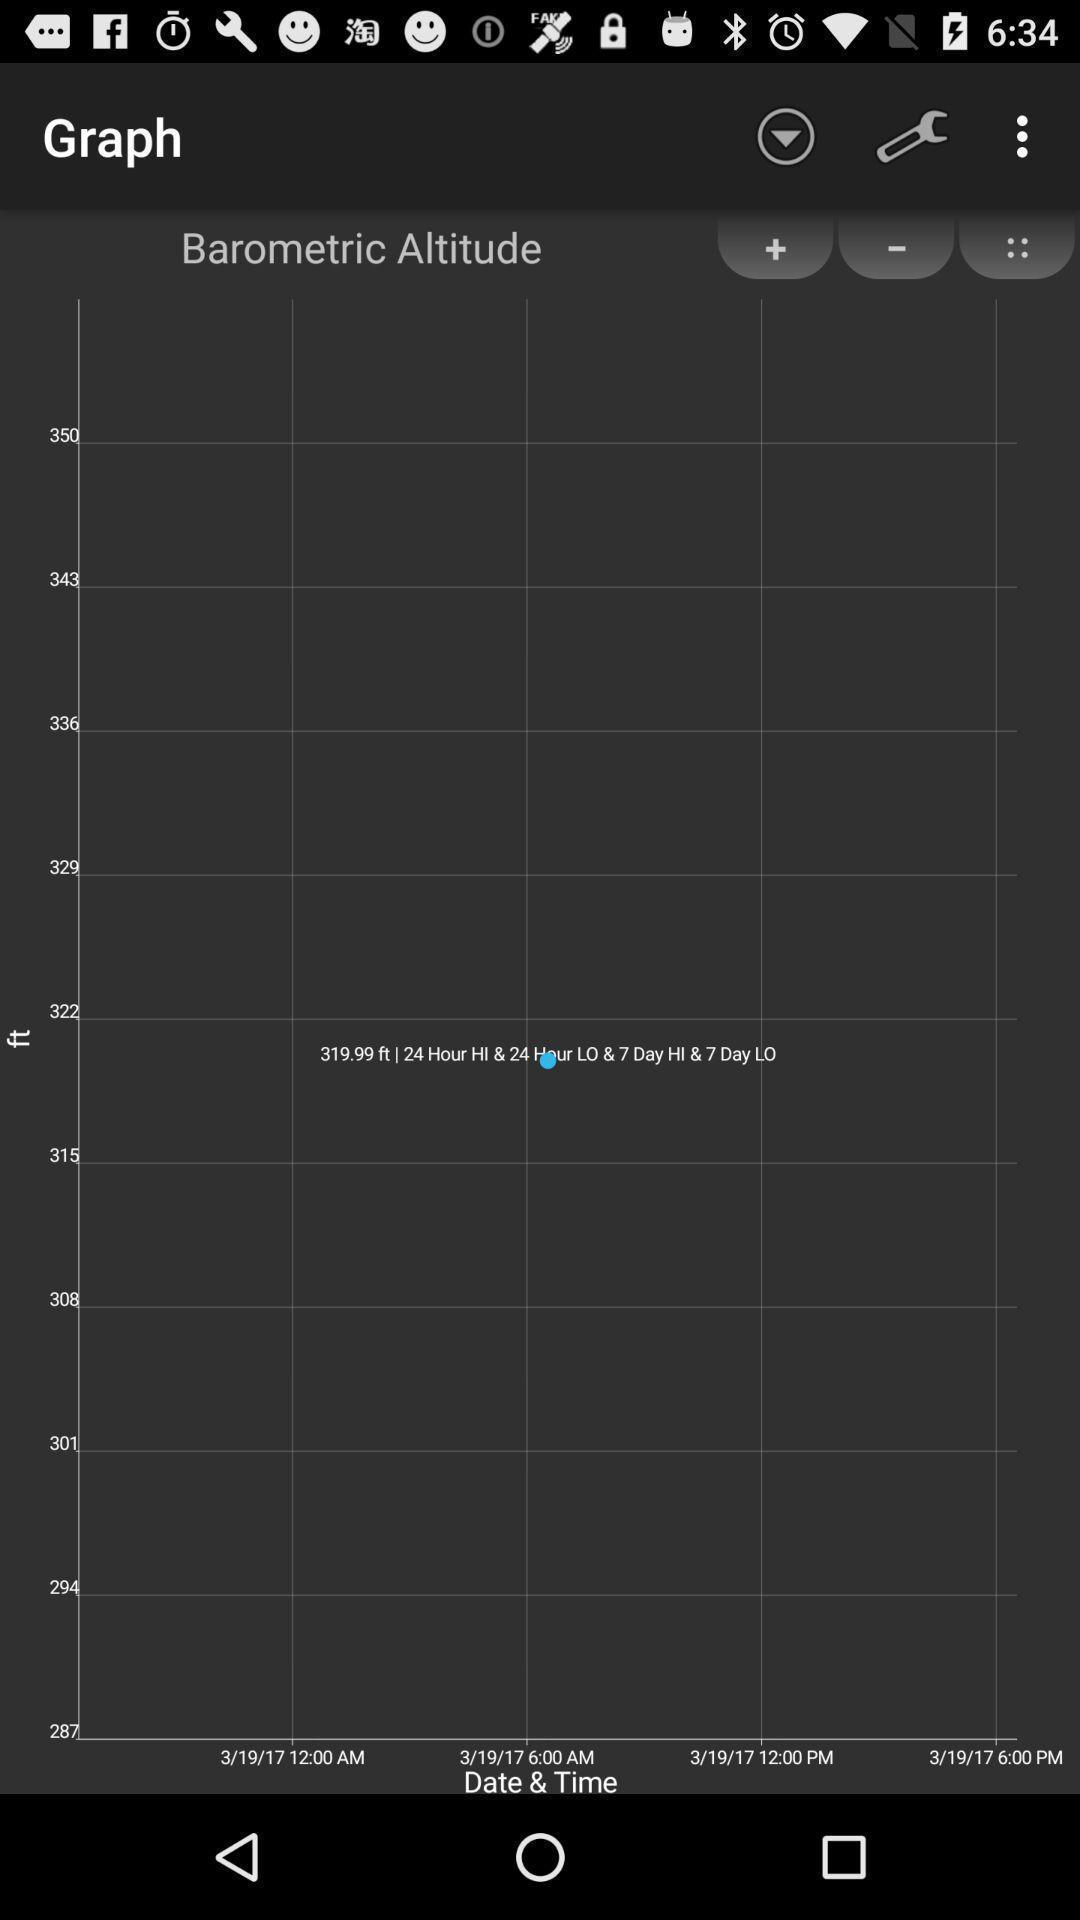Tell me what you see in this picture. Page showing about information in graph. 